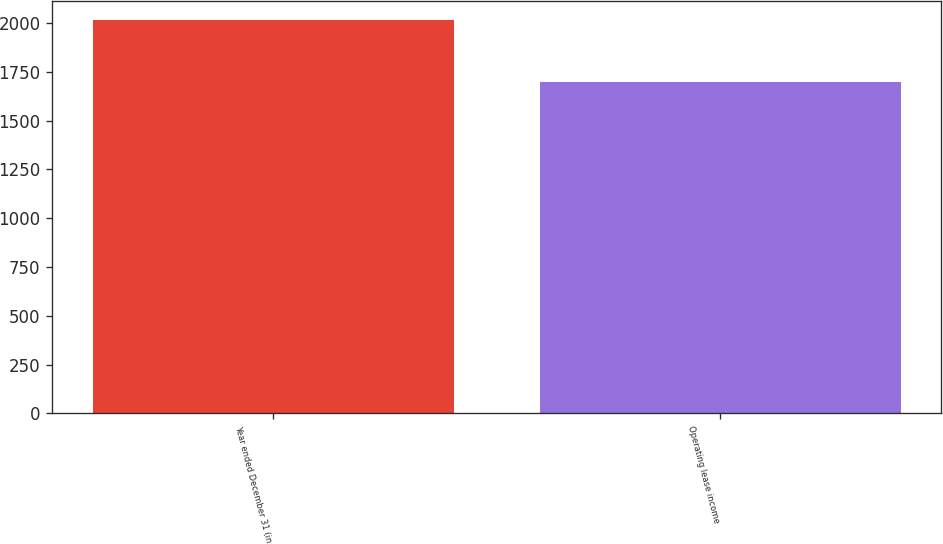Convert chart to OTSL. <chart><loc_0><loc_0><loc_500><loc_500><bar_chart><fcel>Year ended December 31 (in<fcel>Operating lease income<nl><fcel>2014<fcel>1699<nl></chart> 